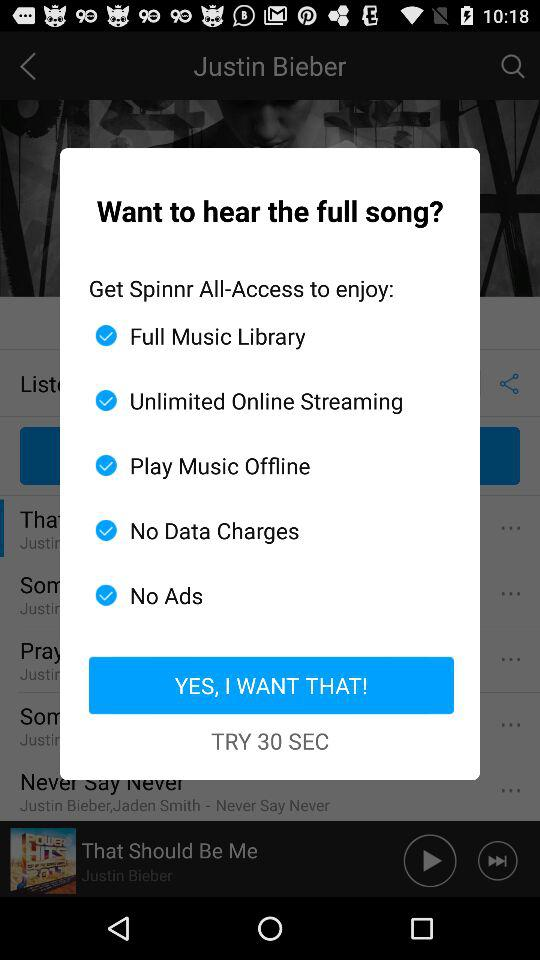How many seconds are displayed on the screen? There are 30 seconds displayed on the screen. 